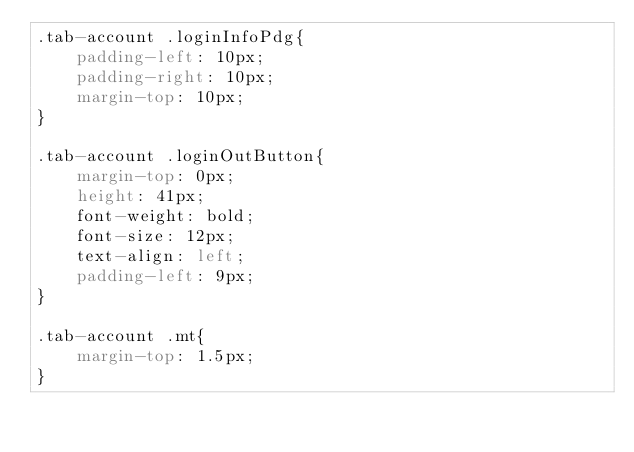Convert code to text. <code><loc_0><loc_0><loc_500><loc_500><_CSS_>.tab-account .loginInfoPdg{
    padding-left: 10px;
    padding-right: 10px;
    margin-top: 10px;
}

.tab-account .loginOutButton{
    margin-top: 0px;
    height: 41px;
    font-weight: bold;
    font-size: 12px;
    text-align: left;
    padding-left: 9px;
}

.tab-account .mt{
    margin-top: 1.5px;
}
</code> 